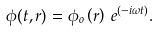Convert formula to latex. <formula><loc_0><loc_0><loc_500><loc_500>\phi ( t , r ) = \phi _ { o } \left ( r \right ) \, e ^ { \left ( - i \omega t \right ) } .</formula> 